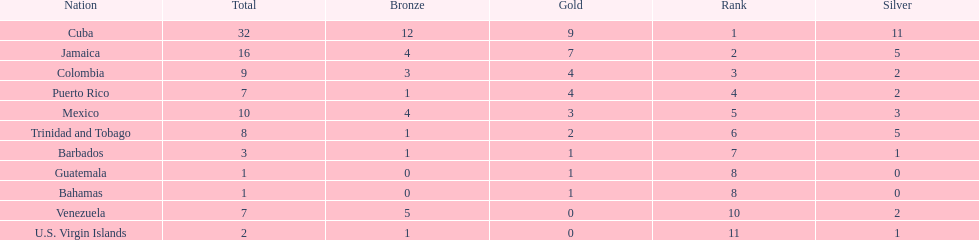The nation before mexico in the table Puerto Rico. 